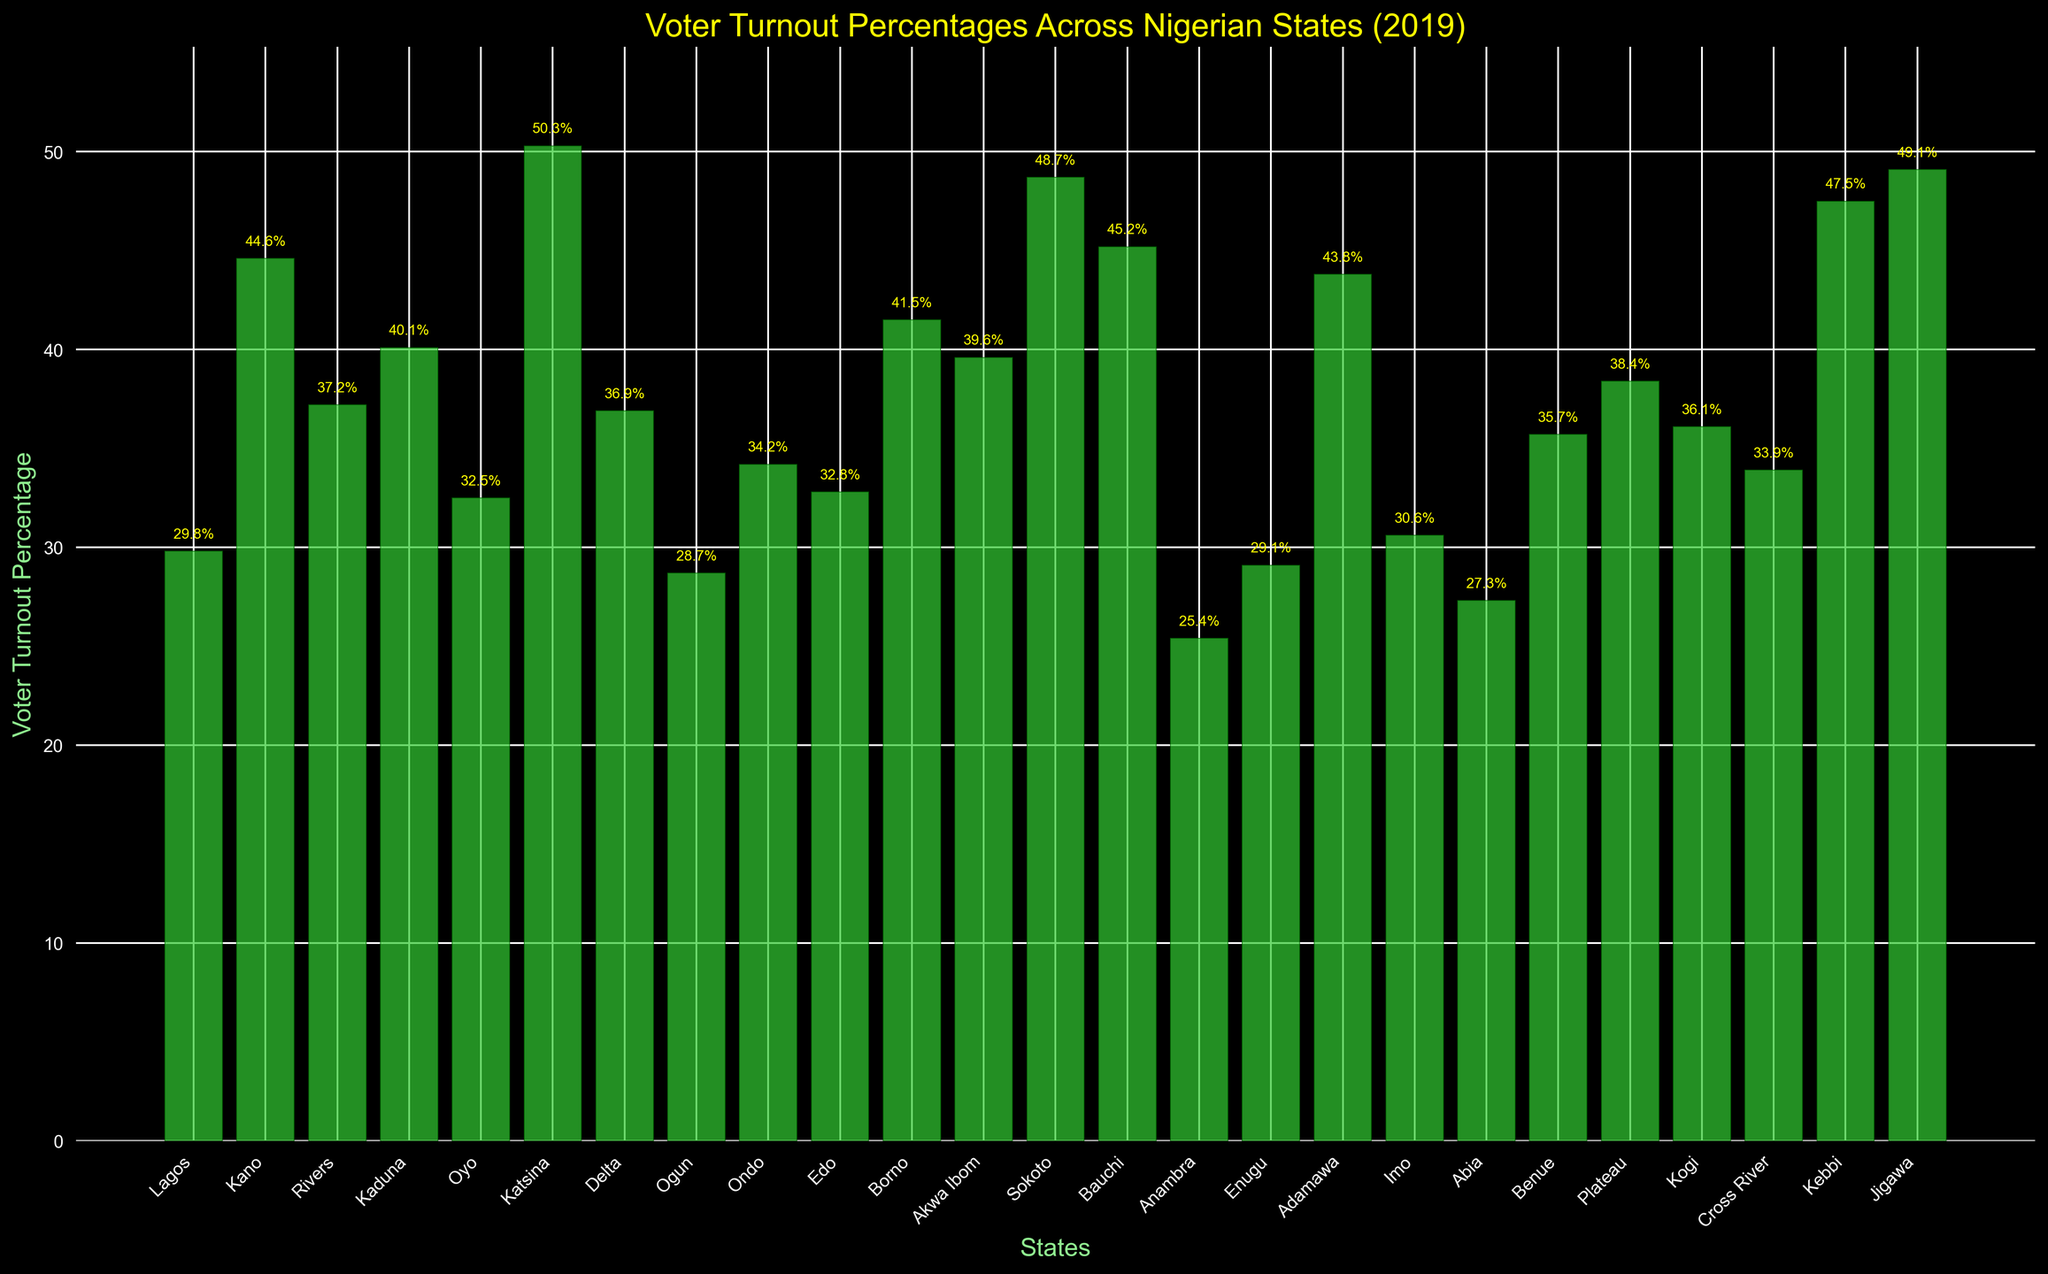Which state had the highest voter turnout percentage? Identify the bar that reaches the highest point on the Y-axis; it represents the state with the highest voter turnout percentage.
Answer: Katsina Compare the voter turnout percentages between Lagos and Kano. Locate the bars for Lagos and Kano. Lagos has a voter turnout of 29.8%, while Kano has 44.6%. Kano's bar is higher than Lagos's bar.
Answer: Kano has a higher voter turnout than Lagos What is the average voter turnout percentage across all the states? Sum up all voter turnout percentages and divide by the number of states. Calculation: (29.8 + 44.6 + 37.2 + 40.1 + 32.5 + 50.3 + 36.9 + 28.7 + 34.2 + 32.8 + 41.5 + 39.6 + 48.7 + 45.2 + 25.4 + 29.1 + 43.8 + 30.6 + 27.3 + 35.7 + 38.4 + 36.1 + 33.9 + 47.5 + 49.1) / 25 ≈ 37.0
Answer: 37.0 Which states have a voter turnout percentage below 30%? Identify the bars that are below the 30% mark on the Y-axis.
Answer: Lagos, Ogun, Anambra, Enugu, Abia How much higher is the voter turnout in Katsina compared to Anambra? Katsina has a voter turnout of 50.3%, and Anambra has 25.4%. Subtract Anambra's percentage from Katsina's: 50.3 - 25.4 = 24.9
Answer: 24.9% Rank the top three states based on voter turnout percentage. Identify the bars that reach the three highest points on the Y-axis and note the respective states.
Answer: Katsina, Jigawa, Sokoto 